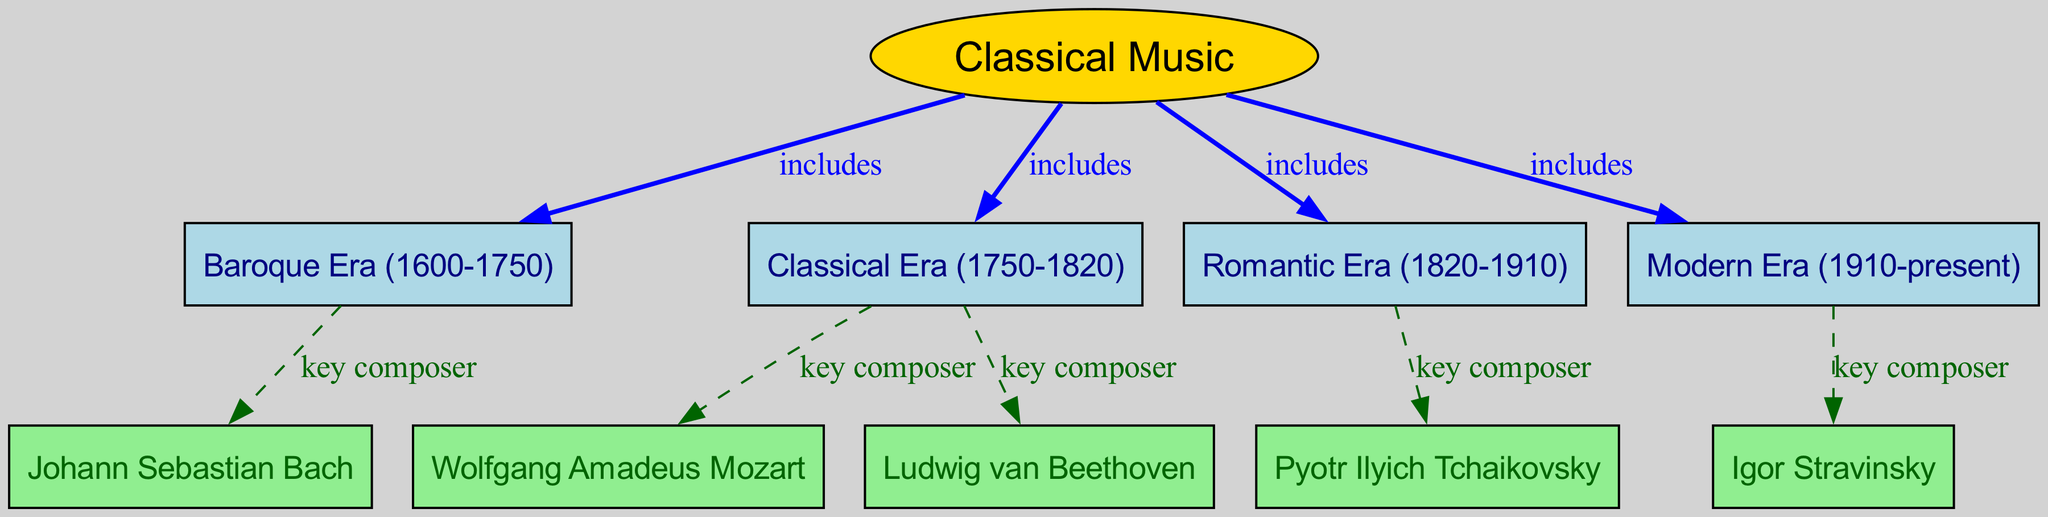What are the four eras included in classical music? The diagram shows that classical music is divided into four eras: Baroque, Classical, Romantic, and Modern. This information is found under the main node "Classical Music".
Answer: Baroque, Classical, Romantic, Modern Who is the key composer of the Romantic Era? The Romantic Era node has a dashed edge connecting it to "Pyotr Ilyich Tchaikovsky" labeled as "key composer". This indicates that Tchaikovsky is recognized as the key composer for this era.
Answer: Pyotr Ilyich Tchaikovsky How many key composers are listed in total? By examining the diagram, we can count the number of key composers connected to each era: Bach, Mozart, Beethoven, Tchaikovsky, and Stravinsky. This gives a total of five key composers across the different eras.
Answer: 5 What is the color used for the Classical Music node? The diagram specifies that the "Classical Music" node is yellow, as indicated by the specific style settings applied in the rendering code for this node.
Answer: Gold Which era includes Ludwig van Beethoven as a key composer? The edge labeled "key composer" connects the "Classical Era" node to "Ludwig van Beethoven", indicating that he is associated with this era. Therefore, Beethoven is a key composer of the Classical Era.
Answer: Classical Era What relationship connects the Baroque Era and Johann Sebastian Bach? The diagram indicates a dashed line labeled "key composer" that connects the "Baroque" node to "Johann Sebastian Bach". This indicates a direct relationship where Bach is recognized as a key composer of the Baroque Era.
Answer: key composer Which era is represented by the most recent key composer listed in the diagram? The "Modern Era" is connected to "Igor Stravinsky", who is noted as a key composer. Since Stravinsky is the last key composer mentioned in the diagram, he represents the most recent era, which is Modern.
Answer: Modern Era What are the edges labeled "includes" connecting to classical music? The edges labeled "includes" connect "Classical Music" to four nodes: Baroque, Classical, Romantic, and Modern. This indicates that these four eras make up the larger category of classical music.
Answer: Baroque, Classical, Romantic, Modern 